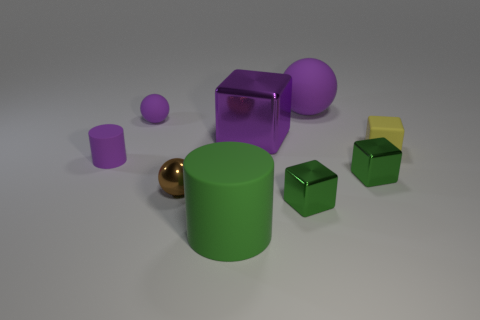There is a purple cylinder; how many big cubes are in front of it? 0 